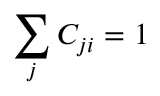<formula> <loc_0><loc_0><loc_500><loc_500>\sum _ { j } { C _ { j i } } = 1</formula> 